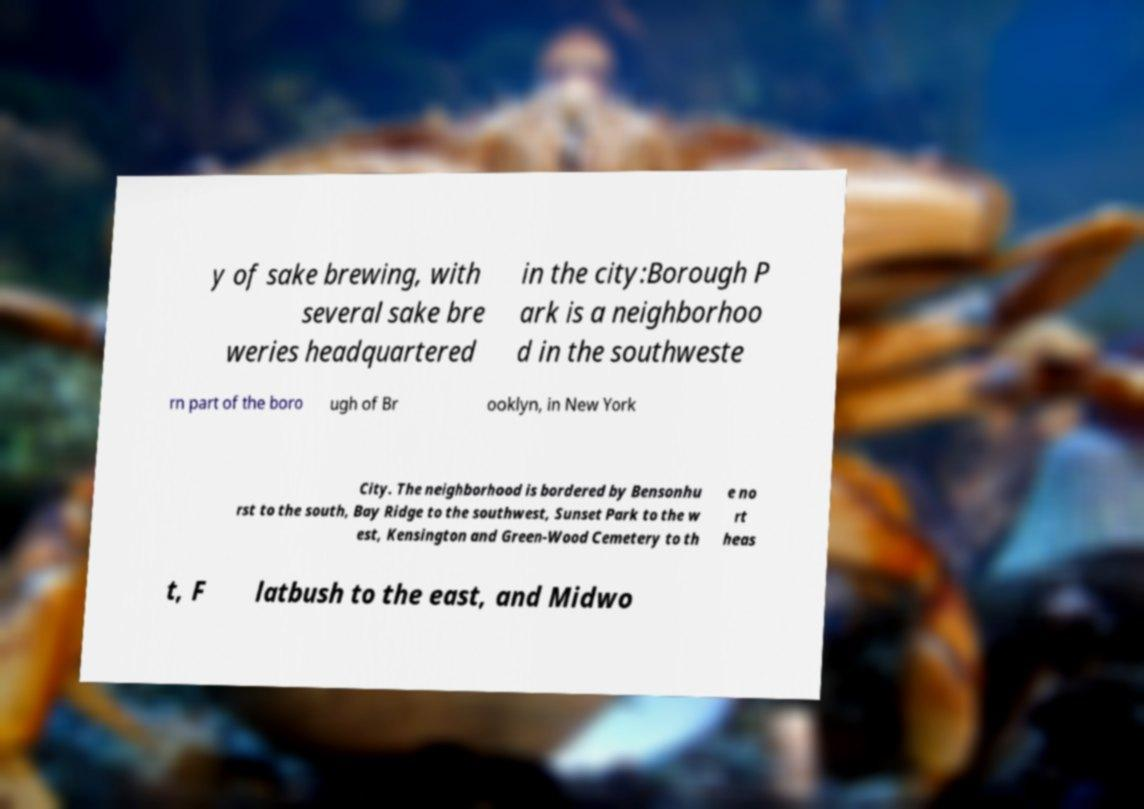Can you read and provide the text displayed in the image?This photo seems to have some interesting text. Can you extract and type it out for me? y of sake brewing, with several sake bre weries headquartered in the city:Borough P ark is a neighborhoo d in the southweste rn part of the boro ugh of Br ooklyn, in New York City. The neighborhood is bordered by Bensonhu rst to the south, Bay Ridge to the southwest, Sunset Park to the w est, Kensington and Green-Wood Cemetery to th e no rt heas t, F latbush to the east, and Midwo 